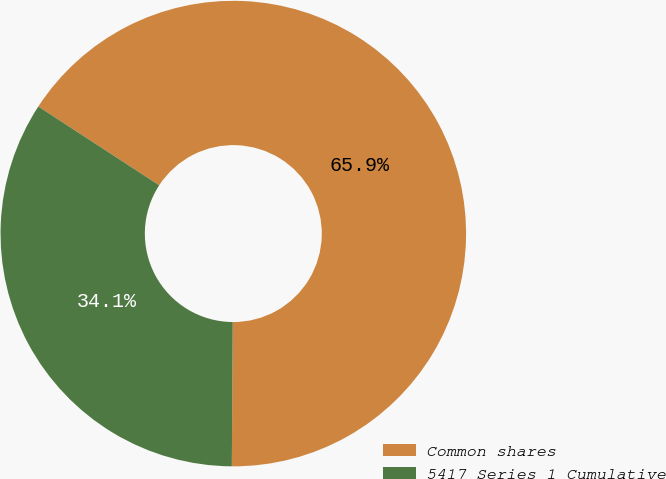Convert chart. <chart><loc_0><loc_0><loc_500><loc_500><pie_chart><fcel>Common shares<fcel>5417 Series 1 Cumulative<nl><fcel>65.91%<fcel>34.09%<nl></chart> 